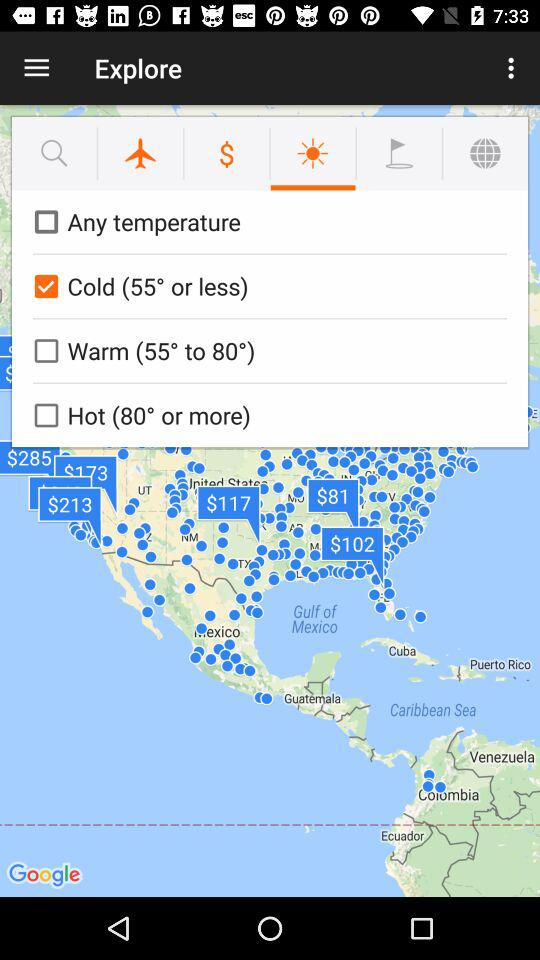What is the status of "Any temperature"? The status of "Any temperature" is "off". 